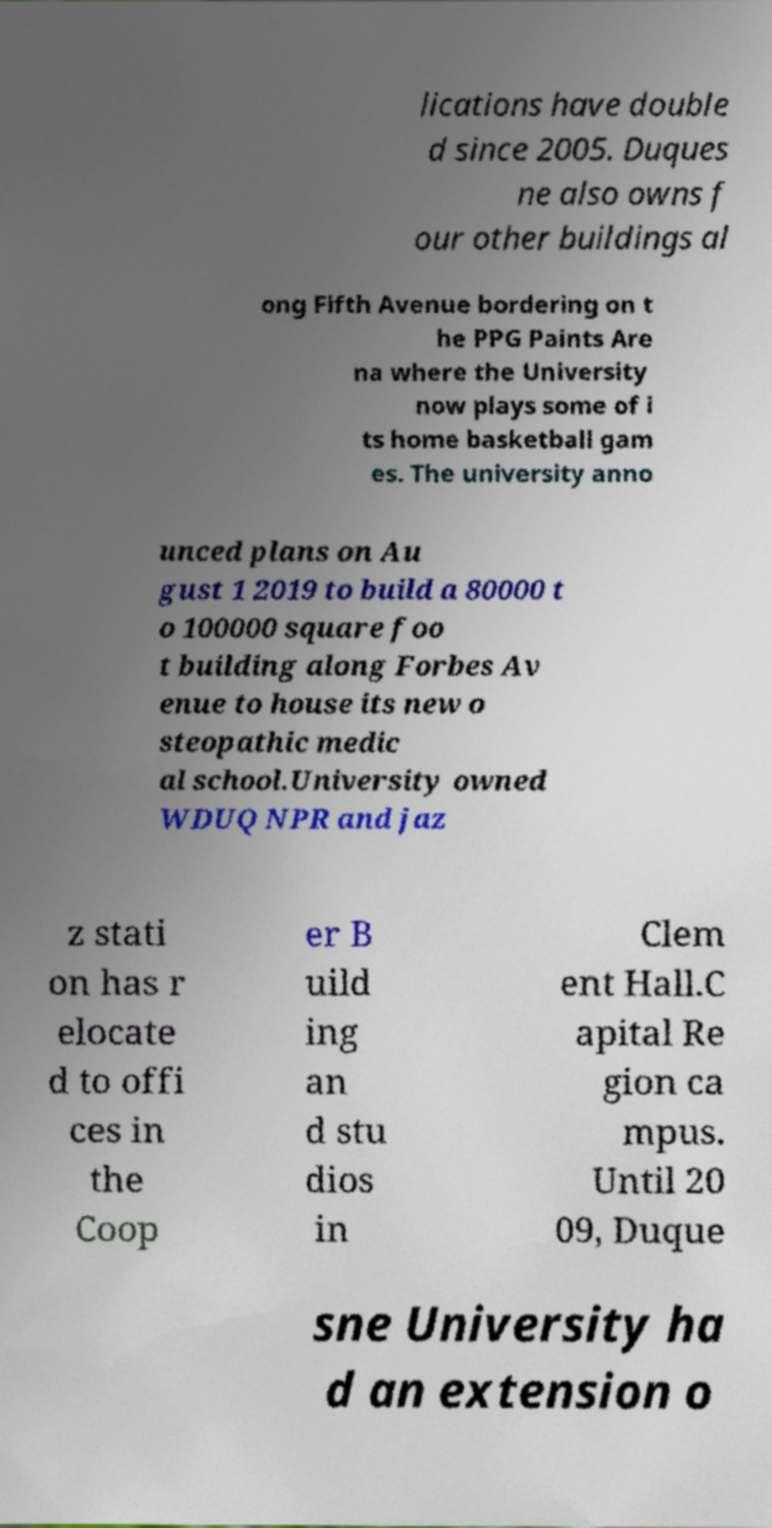Can you accurately transcribe the text from the provided image for me? lications have double d since 2005. Duques ne also owns f our other buildings al ong Fifth Avenue bordering on t he PPG Paints Are na where the University now plays some of i ts home basketball gam es. The university anno unced plans on Au gust 1 2019 to build a 80000 t o 100000 square foo t building along Forbes Av enue to house its new o steopathic medic al school.University owned WDUQ NPR and jaz z stati on has r elocate d to offi ces in the Coop er B uild ing an d stu dios in Clem ent Hall.C apital Re gion ca mpus. Until 20 09, Duque sne University ha d an extension o 